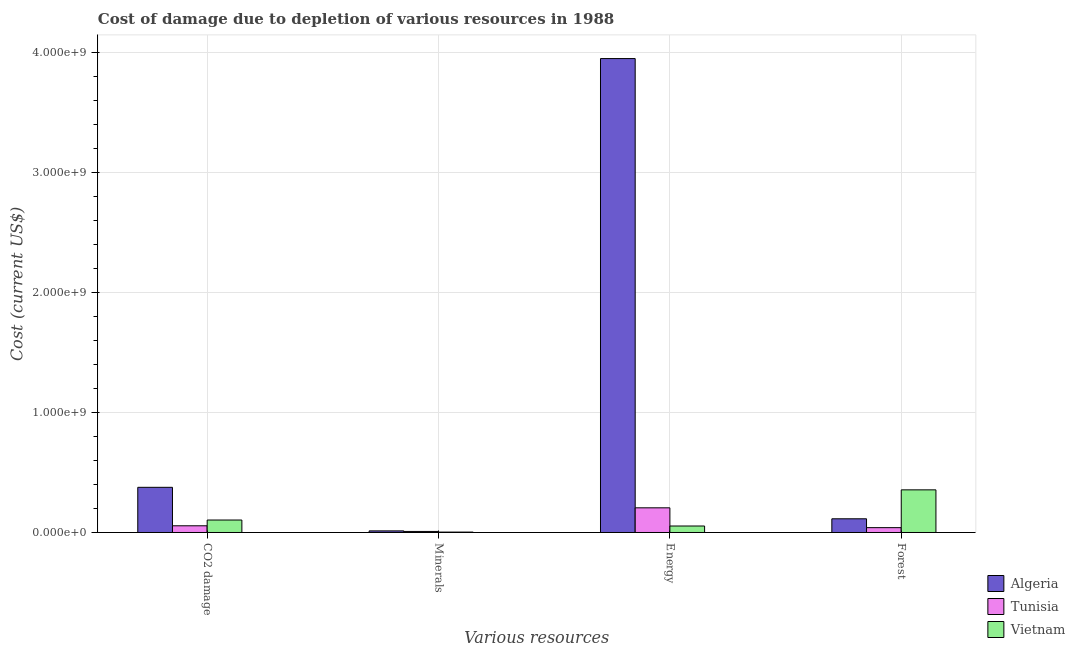Are the number of bars per tick equal to the number of legend labels?
Provide a short and direct response. Yes. Are the number of bars on each tick of the X-axis equal?
Give a very brief answer. Yes. How many bars are there on the 3rd tick from the left?
Your answer should be compact. 3. How many bars are there on the 2nd tick from the right?
Your response must be concise. 3. What is the label of the 3rd group of bars from the left?
Provide a succinct answer. Energy. What is the cost of damage due to depletion of energy in Vietnam?
Give a very brief answer. 5.40e+07. Across all countries, what is the maximum cost of damage due to depletion of minerals?
Offer a terse response. 1.33e+07. Across all countries, what is the minimum cost of damage due to depletion of forests?
Make the answer very short. 4.03e+07. In which country was the cost of damage due to depletion of minerals maximum?
Provide a short and direct response. Algeria. In which country was the cost of damage due to depletion of minerals minimum?
Your answer should be compact. Vietnam. What is the total cost of damage due to depletion of coal in the graph?
Your response must be concise. 5.36e+08. What is the difference between the cost of damage due to depletion of minerals in Tunisia and that in Vietnam?
Offer a terse response. 5.32e+06. What is the difference between the cost of damage due to depletion of minerals in Vietnam and the cost of damage due to depletion of coal in Algeria?
Your answer should be very brief. -3.73e+08. What is the average cost of damage due to depletion of minerals per country?
Keep it short and to the point. 8.43e+06. What is the difference between the cost of damage due to depletion of energy and cost of damage due to depletion of forests in Vietnam?
Offer a terse response. -3.01e+08. What is the ratio of the cost of damage due to depletion of coal in Tunisia to that in Algeria?
Give a very brief answer. 0.15. Is the cost of damage due to depletion of coal in Algeria less than that in Vietnam?
Give a very brief answer. No. Is the difference between the cost of damage due to depletion of minerals in Vietnam and Algeria greater than the difference between the cost of damage due to depletion of forests in Vietnam and Algeria?
Keep it short and to the point. No. What is the difference between the highest and the second highest cost of damage due to depletion of energy?
Provide a succinct answer. 3.74e+09. What is the difference between the highest and the lowest cost of damage due to depletion of minerals?
Give a very brief answer. 1.00e+07. In how many countries, is the cost of damage due to depletion of minerals greater than the average cost of damage due to depletion of minerals taken over all countries?
Your answer should be compact. 2. What does the 1st bar from the left in CO2 damage represents?
Your answer should be compact. Algeria. What does the 2nd bar from the right in Forest represents?
Provide a short and direct response. Tunisia. How many bars are there?
Give a very brief answer. 12. What is the title of the graph?
Offer a terse response. Cost of damage due to depletion of various resources in 1988 . What is the label or title of the X-axis?
Give a very brief answer. Various resources. What is the label or title of the Y-axis?
Ensure brevity in your answer.  Cost (current US$). What is the Cost (current US$) in Algeria in CO2 damage?
Offer a terse response. 3.76e+08. What is the Cost (current US$) in Tunisia in CO2 damage?
Give a very brief answer. 5.59e+07. What is the Cost (current US$) of Vietnam in CO2 damage?
Offer a very short reply. 1.04e+08. What is the Cost (current US$) of Algeria in Minerals?
Provide a short and direct response. 1.33e+07. What is the Cost (current US$) of Tunisia in Minerals?
Your answer should be compact. 8.63e+06. What is the Cost (current US$) of Vietnam in Minerals?
Provide a short and direct response. 3.31e+06. What is the Cost (current US$) of Algeria in Energy?
Your response must be concise. 3.95e+09. What is the Cost (current US$) of Tunisia in Energy?
Your answer should be very brief. 2.06e+08. What is the Cost (current US$) in Vietnam in Energy?
Make the answer very short. 5.40e+07. What is the Cost (current US$) in Algeria in Forest?
Provide a short and direct response. 1.14e+08. What is the Cost (current US$) in Tunisia in Forest?
Offer a terse response. 4.03e+07. What is the Cost (current US$) of Vietnam in Forest?
Keep it short and to the point. 3.55e+08. Across all Various resources, what is the maximum Cost (current US$) of Algeria?
Provide a succinct answer. 3.95e+09. Across all Various resources, what is the maximum Cost (current US$) of Tunisia?
Your response must be concise. 2.06e+08. Across all Various resources, what is the maximum Cost (current US$) of Vietnam?
Give a very brief answer. 3.55e+08. Across all Various resources, what is the minimum Cost (current US$) in Algeria?
Provide a short and direct response. 1.33e+07. Across all Various resources, what is the minimum Cost (current US$) in Tunisia?
Make the answer very short. 8.63e+06. Across all Various resources, what is the minimum Cost (current US$) of Vietnam?
Provide a succinct answer. 3.31e+06. What is the total Cost (current US$) in Algeria in the graph?
Offer a terse response. 4.45e+09. What is the total Cost (current US$) of Tunisia in the graph?
Your response must be concise. 3.10e+08. What is the total Cost (current US$) in Vietnam in the graph?
Ensure brevity in your answer.  5.16e+08. What is the difference between the Cost (current US$) in Algeria in CO2 damage and that in Minerals?
Provide a succinct answer. 3.63e+08. What is the difference between the Cost (current US$) of Tunisia in CO2 damage and that in Minerals?
Your answer should be compact. 4.72e+07. What is the difference between the Cost (current US$) in Vietnam in CO2 damage and that in Minerals?
Provide a succinct answer. 1.01e+08. What is the difference between the Cost (current US$) of Algeria in CO2 damage and that in Energy?
Give a very brief answer. -3.57e+09. What is the difference between the Cost (current US$) of Tunisia in CO2 damage and that in Energy?
Offer a very short reply. -1.50e+08. What is the difference between the Cost (current US$) of Vietnam in CO2 damage and that in Energy?
Ensure brevity in your answer.  4.99e+07. What is the difference between the Cost (current US$) in Algeria in CO2 damage and that in Forest?
Provide a succinct answer. 2.62e+08. What is the difference between the Cost (current US$) in Tunisia in CO2 damage and that in Forest?
Give a very brief answer. 1.55e+07. What is the difference between the Cost (current US$) in Vietnam in CO2 damage and that in Forest?
Your answer should be very brief. -2.51e+08. What is the difference between the Cost (current US$) in Algeria in Minerals and that in Energy?
Provide a succinct answer. -3.93e+09. What is the difference between the Cost (current US$) of Tunisia in Minerals and that in Energy?
Provide a succinct answer. -1.97e+08. What is the difference between the Cost (current US$) in Vietnam in Minerals and that in Energy?
Keep it short and to the point. -5.06e+07. What is the difference between the Cost (current US$) in Algeria in Minerals and that in Forest?
Keep it short and to the point. -1.01e+08. What is the difference between the Cost (current US$) of Tunisia in Minerals and that in Forest?
Keep it short and to the point. -3.17e+07. What is the difference between the Cost (current US$) in Vietnam in Minerals and that in Forest?
Offer a terse response. -3.52e+08. What is the difference between the Cost (current US$) of Algeria in Energy and that in Forest?
Your answer should be compact. 3.83e+09. What is the difference between the Cost (current US$) of Tunisia in Energy and that in Forest?
Your response must be concise. 1.65e+08. What is the difference between the Cost (current US$) in Vietnam in Energy and that in Forest?
Offer a very short reply. -3.01e+08. What is the difference between the Cost (current US$) in Algeria in CO2 damage and the Cost (current US$) in Tunisia in Minerals?
Offer a very short reply. 3.68e+08. What is the difference between the Cost (current US$) in Algeria in CO2 damage and the Cost (current US$) in Vietnam in Minerals?
Your answer should be compact. 3.73e+08. What is the difference between the Cost (current US$) of Tunisia in CO2 damage and the Cost (current US$) of Vietnam in Minerals?
Your answer should be compact. 5.25e+07. What is the difference between the Cost (current US$) in Algeria in CO2 damage and the Cost (current US$) in Tunisia in Energy?
Offer a terse response. 1.71e+08. What is the difference between the Cost (current US$) of Algeria in CO2 damage and the Cost (current US$) of Vietnam in Energy?
Offer a very short reply. 3.22e+08. What is the difference between the Cost (current US$) in Tunisia in CO2 damage and the Cost (current US$) in Vietnam in Energy?
Provide a short and direct response. 1.90e+06. What is the difference between the Cost (current US$) in Algeria in CO2 damage and the Cost (current US$) in Tunisia in Forest?
Your response must be concise. 3.36e+08. What is the difference between the Cost (current US$) in Algeria in CO2 damage and the Cost (current US$) in Vietnam in Forest?
Your response must be concise. 2.11e+07. What is the difference between the Cost (current US$) in Tunisia in CO2 damage and the Cost (current US$) in Vietnam in Forest?
Make the answer very short. -2.99e+08. What is the difference between the Cost (current US$) of Algeria in Minerals and the Cost (current US$) of Tunisia in Energy?
Your answer should be compact. -1.92e+08. What is the difference between the Cost (current US$) in Algeria in Minerals and the Cost (current US$) in Vietnam in Energy?
Your response must be concise. -4.06e+07. What is the difference between the Cost (current US$) of Tunisia in Minerals and the Cost (current US$) of Vietnam in Energy?
Your response must be concise. -4.53e+07. What is the difference between the Cost (current US$) in Algeria in Minerals and the Cost (current US$) in Tunisia in Forest?
Offer a terse response. -2.70e+07. What is the difference between the Cost (current US$) of Algeria in Minerals and the Cost (current US$) of Vietnam in Forest?
Ensure brevity in your answer.  -3.42e+08. What is the difference between the Cost (current US$) in Tunisia in Minerals and the Cost (current US$) in Vietnam in Forest?
Ensure brevity in your answer.  -3.46e+08. What is the difference between the Cost (current US$) of Algeria in Energy and the Cost (current US$) of Tunisia in Forest?
Make the answer very short. 3.91e+09. What is the difference between the Cost (current US$) in Algeria in Energy and the Cost (current US$) in Vietnam in Forest?
Offer a terse response. 3.59e+09. What is the difference between the Cost (current US$) of Tunisia in Energy and the Cost (current US$) of Vietnam in Forest?
Provide a short and direct response. -1.50e+08. What is the average Cost (current US$) in Algeria per Various resources?
Keep it short and to the point. 1.11e+09. What is the average Cost (current US$) in Tunisia per Various resources?
Offer a very short reply. 7.76e+07. What is the average Cost (current US$) of Vietnam per Various resources?
Make the answer very short. 1.29e+08. What is the difference between the Cost (current US$) in Algeria and Cost (current US$) in Tunisia in CO2 damage?
Give a very brief answer. 3.20e+08. What is the difference between the Cost (current US$) in Algeria and Cost (current US$) in Vietnam in CO2 damage?
Make the answer very short. 2.72e+08. What is the difference between the Cost (current US$) of Tunisia and Cost (current US$) of Vietnam in CO2 damage?
Your answer should be compact. -4.80e+07. What is the difference between the Cost (current US$) of Algeria and Cost (current US$) of Tunisia in Minerals?
Ensure brevity in your answer.  4.71e+06. What is the difference between the Cost (current US$) in Algeria and Cost (current US$) in Vietnam in Minerals?
Provide a succinct answer. 1.00e+07. What is the difference between the Cost (current US$) of Tunisia and Cost (current US$) of Vietnam in Minerals?
Your answer should be compact. 5.32e+06. What is the difference between the Cost (current US$) in Algeria and Cost (current US$) in Tunisia in Energy?
Provide a short and direct response. 3.74e+09. What is the difference between the Cost (current US$) in Algeria and Cost (current US$) in Vietnam in Energy?
Provide a succinct answer. 3.89e+09. What is the difference between the Cost (current US$) of Tunisia and Cost (current US$) of Vietnam in Energy?
Your response must be concise. 1.52e+08. What is the difference between the Cost (current US$) of Algeria and Cost (current US$) of Tunisia in Forest?
Make the answer very short. 7.38e+07. What is the difference between the Cost (current US$) of Algeria and Cost (current US$) of Vietnam in Forest?
Your answer should be compact. -2.41e+08. What is the difference between the Cost (current US$) in Tunisia and Cost (current US$) in Vietnam in Forest?
Offer a terse response. -3.15e+08. What is the ratio of the Cost (current US$) in Algeria in CO2 damage to that in Minerals?
Offer a very short reply. 28.19. What is the ratio of the Cost (current US$) of Tunisia in CO2 damage to that in Minerals?
Make the answer very short. 6.47. What is the ratio of the Cost (current US$) of Vietnam in CO2 damage to that in Minerals?
Your response must be concise. 31.39. What is the ratio of the Cost (current US$) of Algeria in CO2 damage to that in Energy?
Your response must be concise. 0.1. What is the ratio of the Cost (current US$) in Tunisia in CO2 damage to that in Energy?
Ensure brevity in your answer.  0.27. What is the ratio of the Cost (current US$) in Vietnam in CO2 damage to that in Energy?
Your answer should be very brief. 1.93. What is the ratio of the Cost (current US$) in Algeria in CO2 damage to that in Forest?
Provide a short and direct response. 3.3. What is the ratio of the Cost (current US$) in Tunisia in CO2 damage to that in Forest?
Make the answer very short. 1.39. What is the ratio of the Cost (current US$) of Vietnam in CO2 damage to that in Forest?
Your response must be concise. 0.29. What is the ratio of the Cost (current US$) of Algeria in Minerals to that in Energy?
Your response must be concise. 0. What is the ratio of the Cost (current US$) in Tunisia in Minerals to that in Energy?
Your answer should be very brief. 0.04. What is the ratio of the Cost (current US$) in Vietnam in Minerals to that in Energy?
Make the answer very short. 0.06. What is the ratio of the Cost (current US$) in Algeria in Minerals to that in Forest?
Provide a succinct answer. 0.12. What is the ratio of the Cost (current US$) in Tunisia in Minerals to that in Forest?
Make the answer very short. 0.21. What is the ratio of the Cost (current US$) of Vietnam in Minerals to that in Forest?
Your answer should be very brief. 0.01. What is the ratio of the Cost (current US$) in Algeria in Energy to that in Forest?
Ensure brevity in your answer.  34.6. What is the ratio of the Cost (current US$) in Tunisia in Energy to that in Forest?
Keep it short and to the point. 5.1. What is the ratio of the Cost (current US$) of Vietnam in Energy to that in Forest?
Ensure brevity in your answer.  0.15. What is the difference between the highest and the second highest Cost (current US$) in Algeria?
Give a very brief answer. 3.57e+09. What is the difference between the highest and the second highest Cost (current US$) of Tunisia?
Offer a terse response. 1.50e+08. What is the difference between the highest and the second highest Cost (current US$) of Vietnam?
Offer a terse response. 2.51e+08. What is the difference between the highest and the lowest Cost (current US$) in Algeria?
Keep it short and to the point. 3.93e+09. What is the difference between the highest and the lowest Cost (current US$) in Tunisia?
Make the answer very short. 1.97e+08. What is the difference between the highest and the lowest Cost (current US$) in Vietnam?
Give a very brief answer. 3.52e+08. 